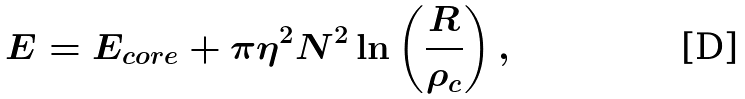Convert formula to latex. <formula><loc_0><loc_0><loc_500><loc_500>E = E _ { c o r e } + \pi \eta ^ { 2 } N ^ { 2 } \ln \left ( \frac { R } { \rho _ { c } } \right ) ,</formula> 